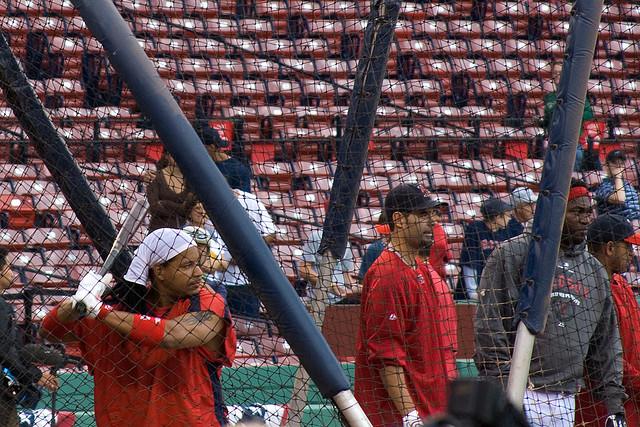Is this a full stadium?
Concise answer only. No. Is this a professional baseball team?
Write a very short answer. Yes. What color is the bat?
Write a very short answer. Black. 